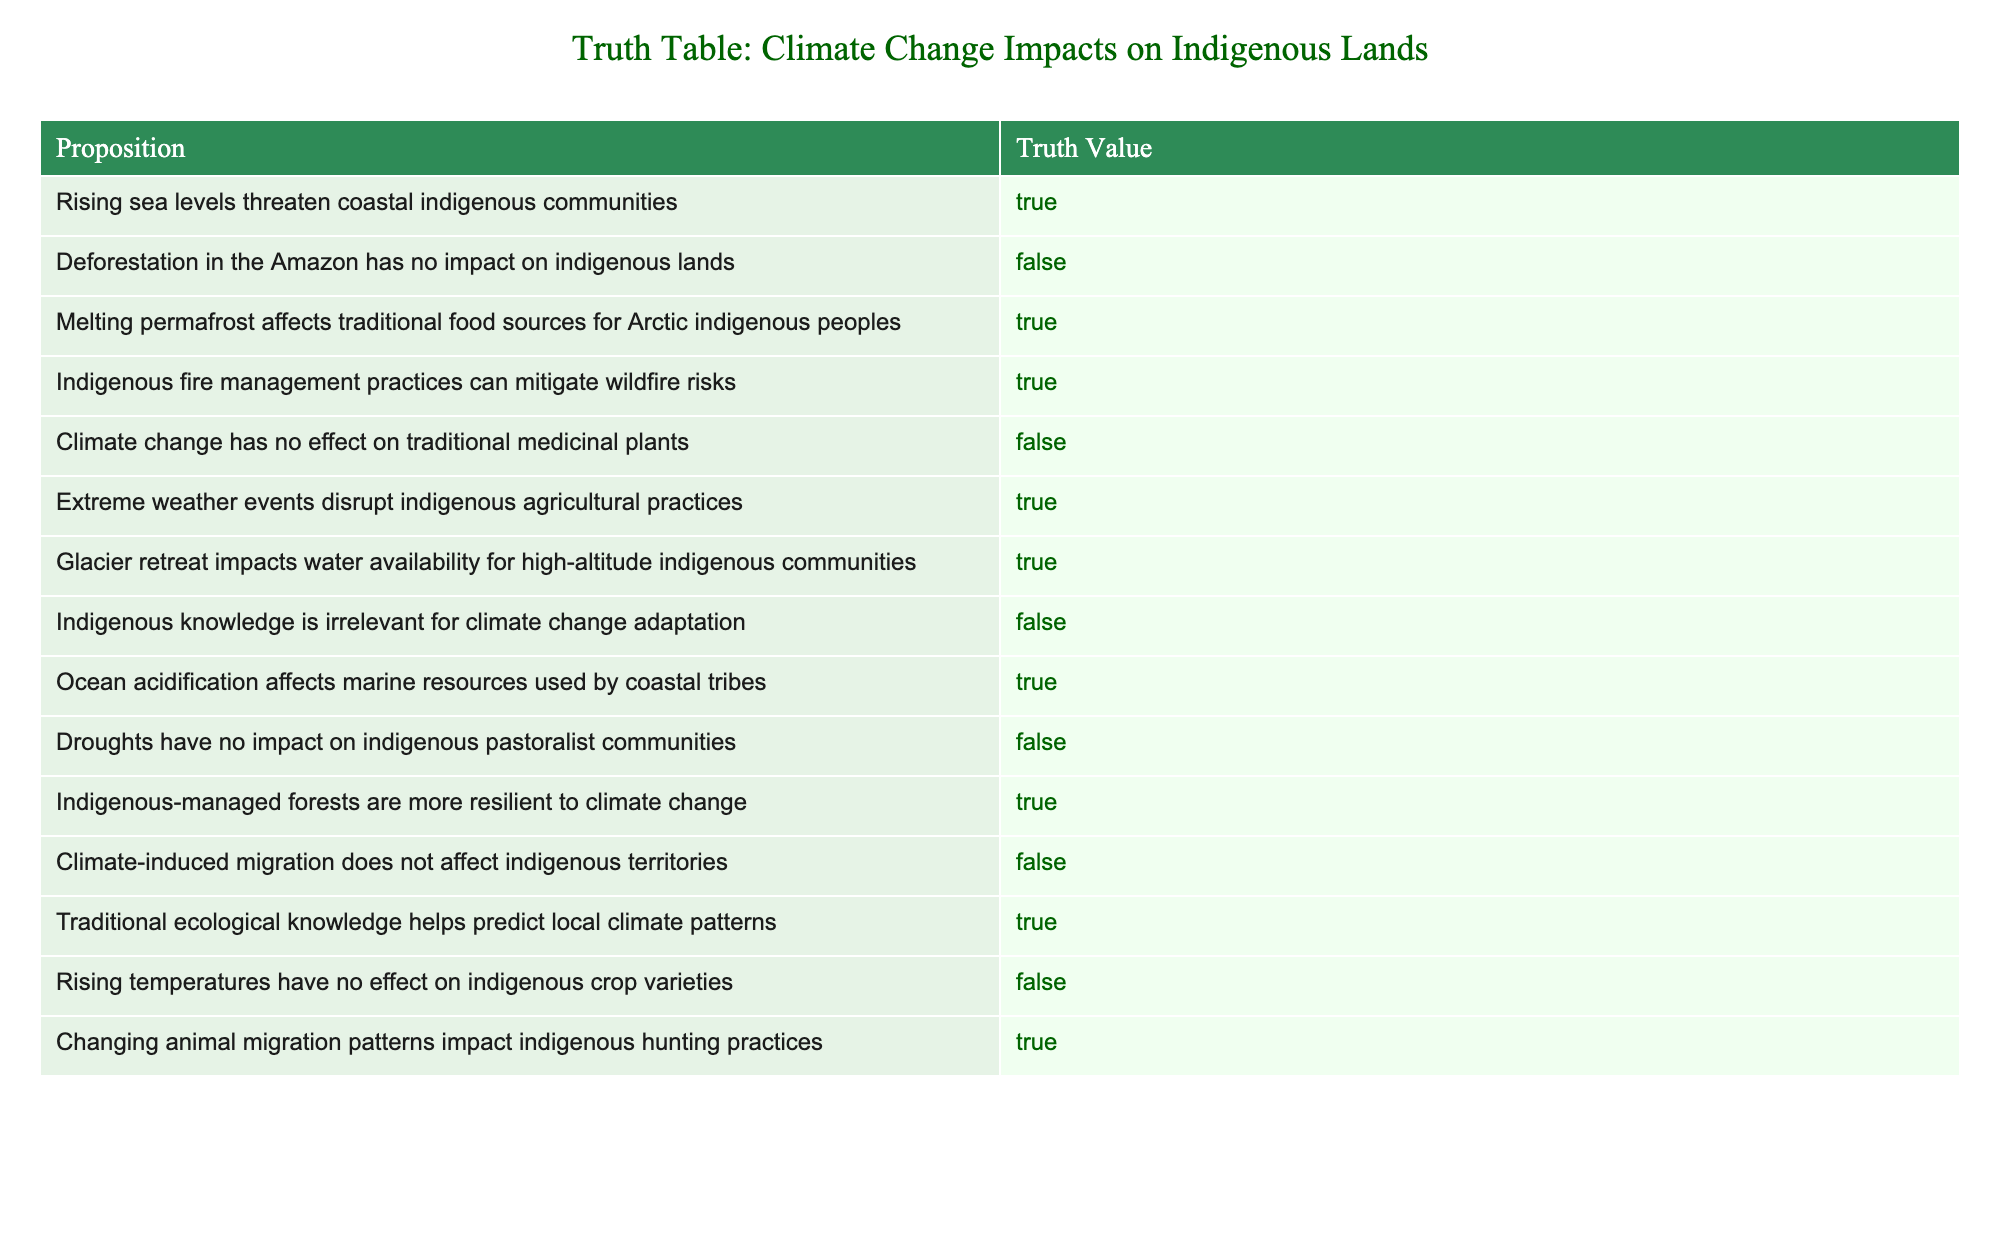What are the true propositions regarding climate change impacts on indigenous communities? The table lists several propositions, and by identifying those with a truth value of "True," we see that they highlight significant concerns and realities facing indigenous communities due to climate change.
Answer: Rising sea levels threaten coastal indigenous communities, Melting permafrost affects traditional food sources for Arctic indigenous peoples, Indigenous fire management practices can mitigate wildfire risks, Extreme weather events disrupt indigenous agricultural practices, Glacier retreat impacts water availability for high-altitude indigenous communities, Ocean acidification affects marine resources used by coastal tribes, Indigenous-managed forests are more resilient to climate change, Traditional ecological knowledge helps predict local climate patterns, Changing animal migration patterns impact indigenous hunting practices What is the total number of propositions that indicate a negative impact of climate change on indigenous lands? We need to count the propositions in the table that have a truth value of "False." There are six such propositions: Deforestation in the Amazon has no impact, Climate change has no effect on traditional medicinal plants, Droughts have no impact on indigenous pastoralist communities, Indigenous knowledge is irrelevant for climate change adaptation, Rising temperatures have no effect on indigenous crop varieties, Climate-induced migration does not affect indigenous territories. Thus, the total is six.
Answer: 6 Are extreme weather events disruptive to indigenous agricultural practices? By referring to the table, we can see that the statement regarding extreme weather events disrupting indigenous agricultural practices is classified as "True."
Answer: Yes What are the implications of glacier retreat on indigenous communities according to the table? The table states that glacier retreat impacts water availability for high-altitude indigenous communities, indicating a direct relationship between glacier retreat and essential resources for these communities. Therefore, glacier retreat poses significant risks to water access and sustainability for indigenous peoples living in high-altitude regions.
Answer: Glacier retreat impacts water availability How many propositions state that indigenous knowledge is irrelevant for climate change adaptation? The table includes one proposition that states indigenous knowledge is irrelevant for climate change adaptation and its truth value is "False." This means that it acknowledges the importance of indigenous knowledge in the context of climate change adaptation.
Answer: 1 What is the impact of rising temperatures on indigenous crop varieties according to the table? The proposition in the table states that rising temperatures have no effect on indigenous crop varieties, and its truth value is "False." This indicates that rising temperatures do indeed have an impact on indigenous crop varieties, suggesting potential threats to agricultural practices.
Answer: Rising temperatures affect indigenous crop varieties 